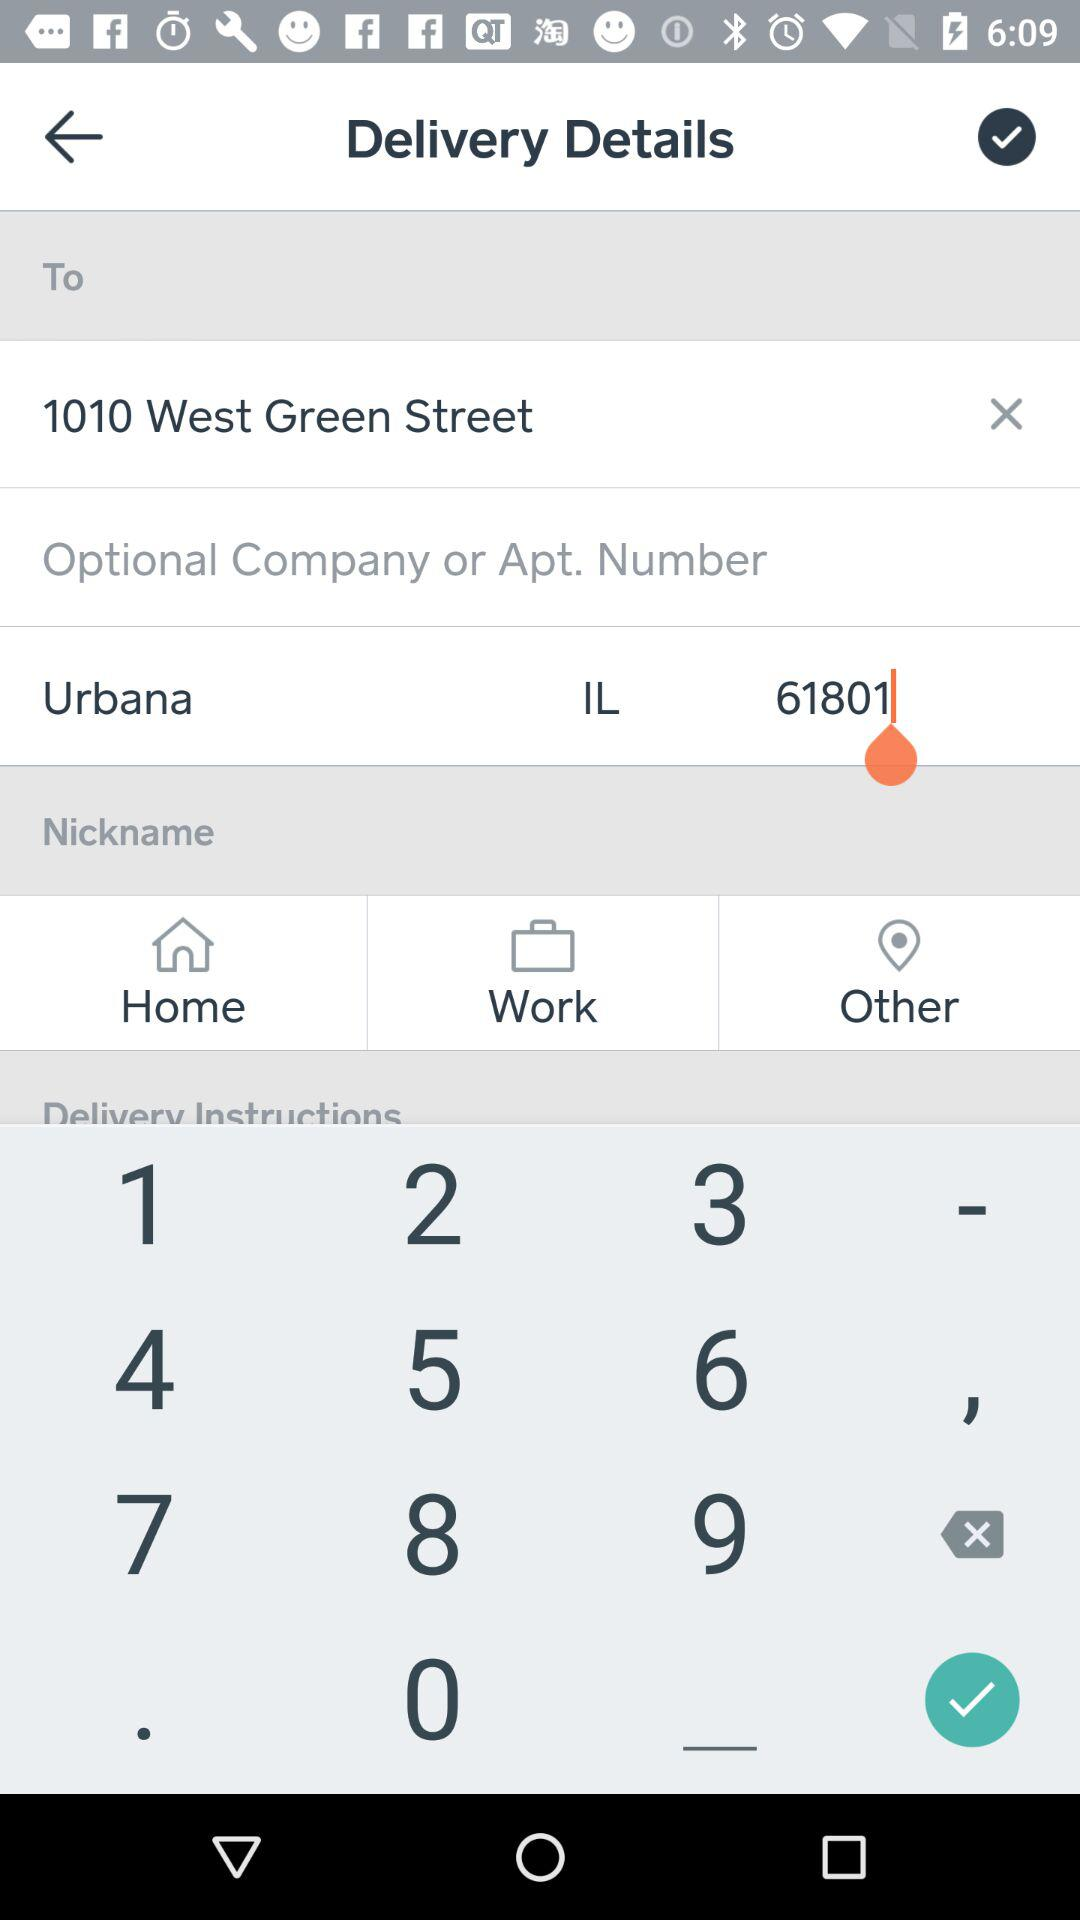How many items are in the delivery address?
Answer the question using a single word or phrase. 3 